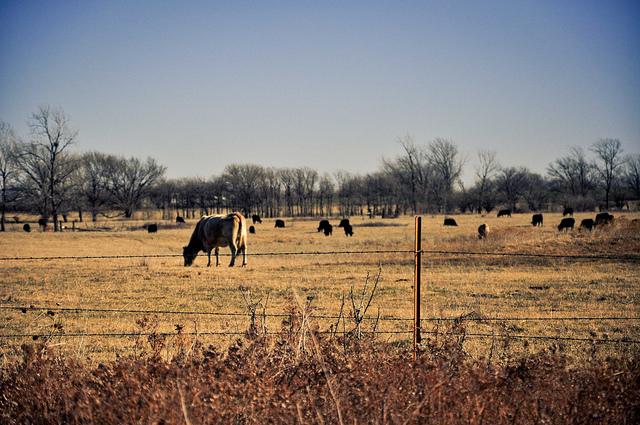How are these animals protected from the cold?
Short answer required. Fur. How many fence posts are there?
Quick response, please. 1. Is this a sunny day?
Short answer required. Yes. What is the cow doing?
Be succinct. Grazing. How many birds on the wire?
Answer briefly. 0. Is it daytime or nighttime?
Write a very short answer. Daytime. What is between the photographer and the animals?
Answer briefly. Fence. 